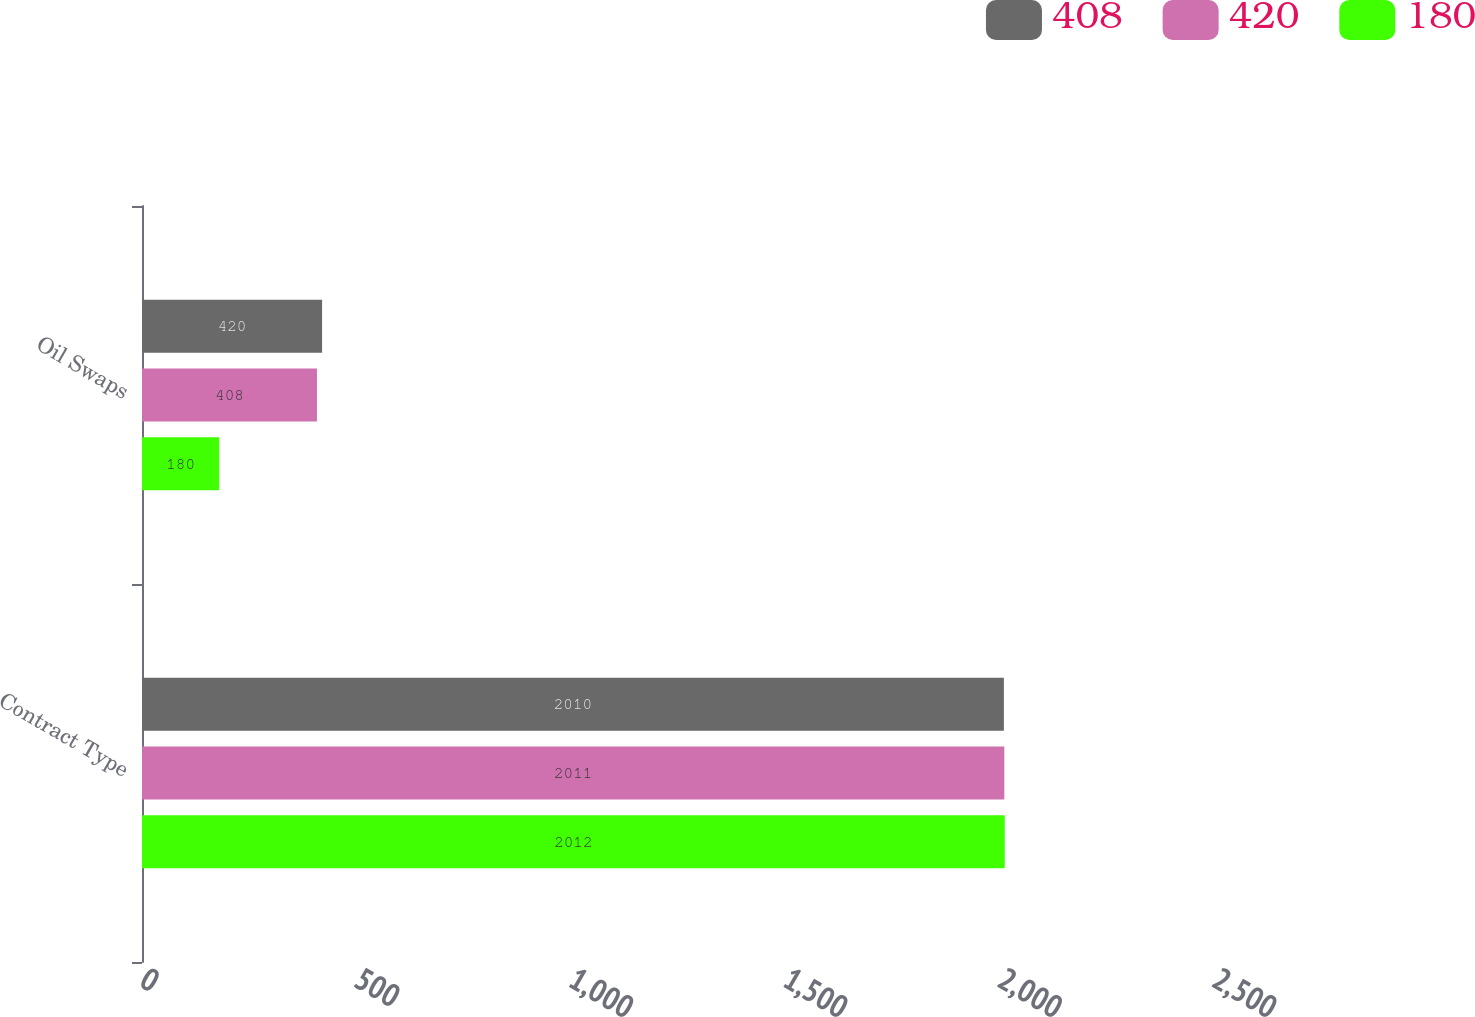Convert chart. <chart><loc_0><loc_0><loc_500><loc_500><stacked_bar_chart><ecel><fcel>Contract Type<fcel>Oil Swaps<nl><fcel>408<fcel>2010<fcel>420<nl><fcel>420<fcel>2011<fcel>408<nl><fcel>180<fcel>2012<fcel>180<nl></chart> 